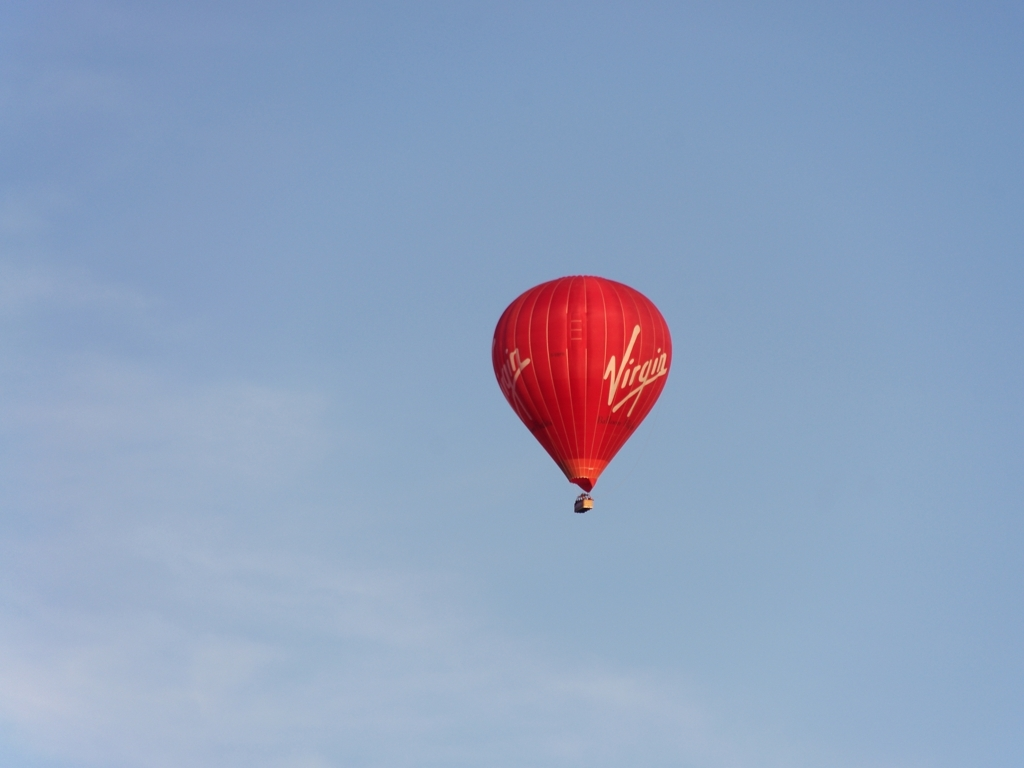Are there any noticeable noise or artifacts in the image? The image appears to have been captured with a high-quality camera, as there are no visible signs of noise or artifacts that would suggest a low-resolution or poorly taken photograph. 